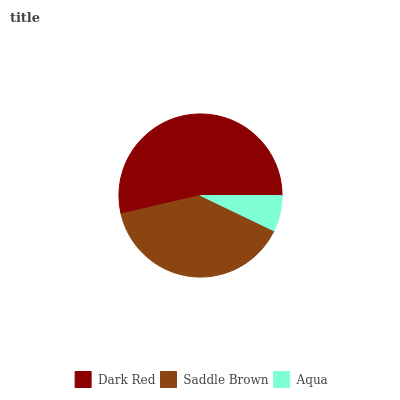Is Aqua the minimum?
Answer yes or no. Yes. Is Dark Red the maximum?
Answer yes or no. Yes. Is Saddle Brown the minimum?
Answer yes or no. No. Is Saddle Brown the maximum?
Answer yes or no. No. Is Dark Red greater than Saddle Brown?
Answer yes or no. Yes. Is Saddle Brown less than Dark Red?
Answer yes or no. Yes. Is Saddle Brown greater than Dark Red?
Answer yes or no. No. Is Dark Red less than Saddle Brown?
Answer yes or no. No. Is Saddle Brown the high median?
Answer yes or no. Yes. Is Saddle Brown the low median?
Answer yes or no. Yes. Is Dark Red the high median?
Answer yes or no. No. Is Aqua the low median?
Answer yes or no. No. 